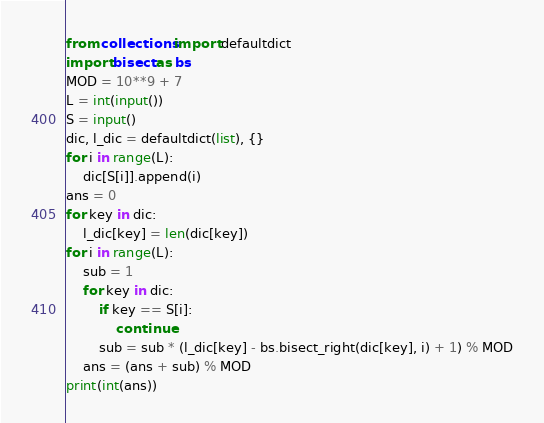<code> <loc_0><loc_0><loc_500><loc_500><_Python_>from collections import defaultdict
import bisect as bs
MOD = 10**9 + 7
L = int(input())
S = input()
dic, l_dic = defaultdict(list), {}
for i in range(L):
    dic[S[i]].append(i)
ans = 0
for key in dic:
    l_dic[key] = len(dic[key])
for i in range(L):
    sub = 1
    for key in dic:
        if key == S[i]:
            continue
        sub = sub * (l_dic[key] - bs.bisect_right(dic[key], i) + 1) % MOD
    ans = (ans + sub) % MOD
print(int(ans))</code> 